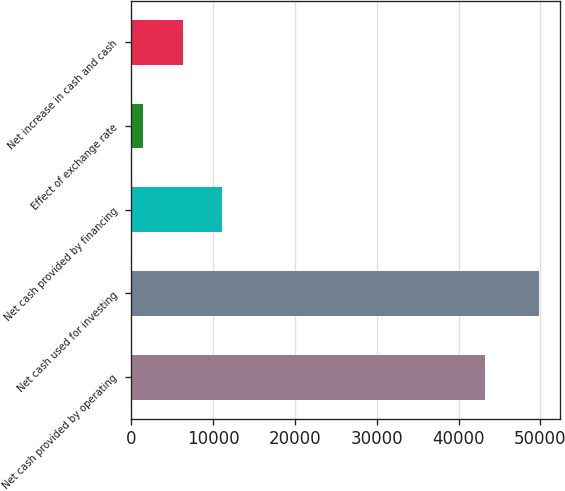Convert chart to OTSL. <chart><loc_0><loc_0><loc_500><loc_500><bar_chart><fcel>Net cash provided by operating<fcel>Net cash used for investing<fcel>Net cash provided by financing<fcel>Effect of exchange rate<fcel>Net increase in cash and cash<nl><fcel>43290<fcel>49863<fcel>11144.6<fcel>1465<fcel>6304.8<nl></chart> 